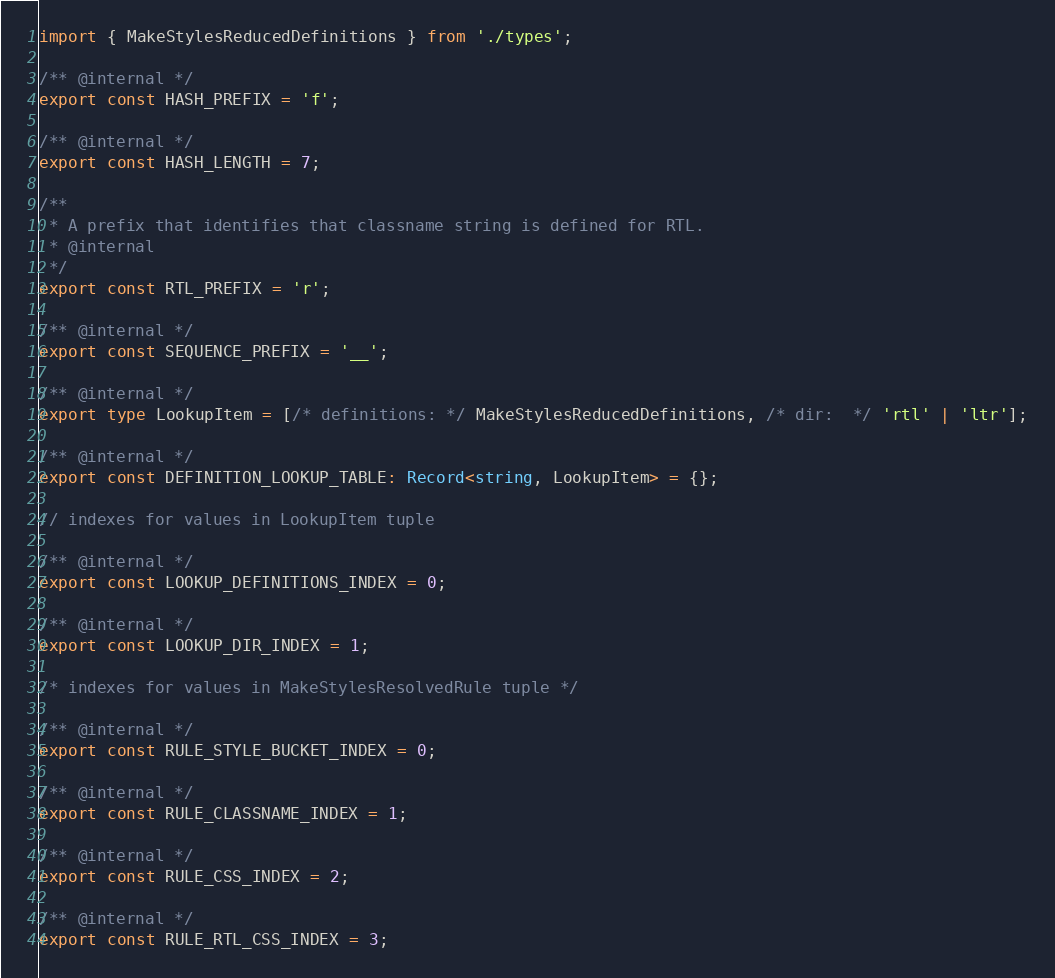Convert code to text. <code><loc_0><loc_0><loc_500><loc_500><_TypeScript_>import { MakeStylesReducedDefinitions } from './types';

/** @internal */
export const HASH_PREFIX = 'f';

/** @internal */
export const HASH_LENGTH = 7;

/**
 * A prefix that identifies that classname string is defined for RTL.
 * @internal
 */
export const RTL_PREFIX = 'r';

/** @internal */
export const SEQUENCE_PREFIX = '__';

/** @internal */
export type LookupItem = [/* definitions: */ MakeStylesReducedDefinitions, /* dir:  */ 'rtl' | 'ltr'];

/** @internal */
export const DEFINITION_LOOKUP_TABLE: Record<string, LookupItem> = {};

// indexes for values in LookupItem tuple

/** @internal */
export const LOOKUP_DEFINITIONS_INDEX = 0;

/** @internal */
export const LOOKUP_DIR_INDEX = 1;

/* indexes for values in MakeStylesResolvedRule tuple */

/** @internal */
export const RULE_STYLE_BUCKET_INDEX = 0;

/** @internal */
export const RULE_CLASSNAME_INDEX = 1;

/** @internal */
export const RULE_CSS_INDEX = 2;

/** @internal */
export const RULE_RTL_CSS_INDEX = 3;
</code> 